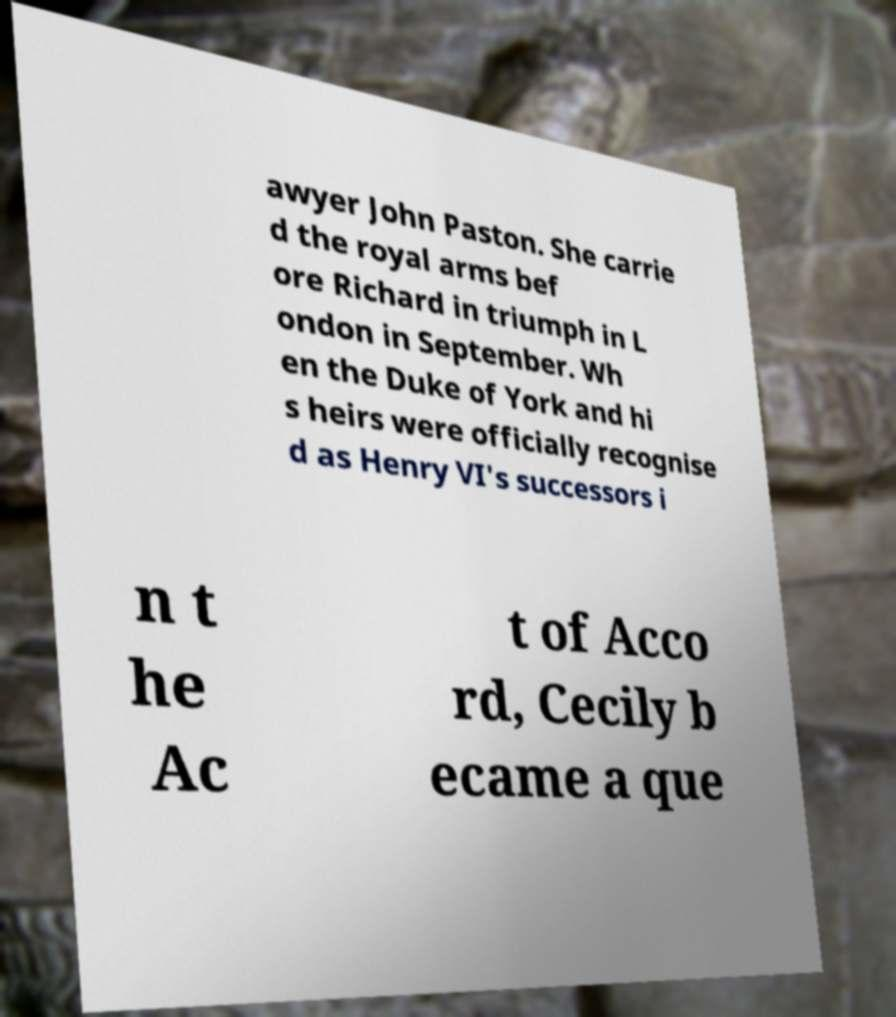Can you read and provide the text displayed in the image?This photo seems to have some interesting text. Can you extract and type it out for me? awyer John Paston. She carrie d the royal arms bef ore Richard in triumph in L ondon in September. Wh en the Duke of York and hi s heirs were officially recognise d as Henry VI's successors i n t he Ac t of Acco rd, Cecily b ecame a que 